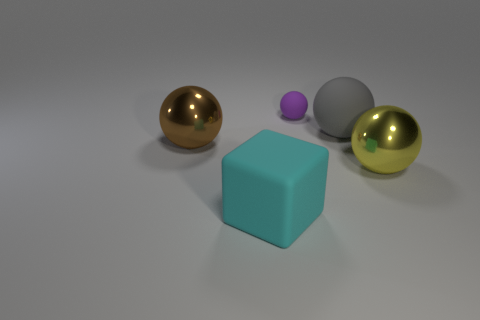Are there more small purple metallic spheres than cyan objects?
Make the answer very short. No. How many large rubber objects are both behind the brown shiny ball and on the left side of the purple sphere?
Your answer should be very brief. 0. Is there anything else that has the same size as the gray matte object?
Keep it short and to the point. Yes. Are there more purple matte spheres that are in front of the large brown sphere than large metal things that are right of the purple matte object?
Make the answer very short. No. There is a large ball to the left of the purple matte sphere; what is it made of?
Offer a very short reply. Metal. Does the large yellow metal object have the same shape as the tiny purple matte object that is to the left of the large gray rubber object?
Your response must be concise. Yes. There is a metallic thing that is behind the large metal thing on the right side of the purple sphere; how many yellow things are behind it?
Make the answer very short. 0. The other matte object that is the same shape as the big gray thing is what color?
Ensure brevity in your answer.  Purple. Is there any other thing that has the same shape as the large yellow metallic thing?
Your response must be concise. Yes. How many blocks are either tiny purple things or yellow shiny things?
Give a very brief answer. 0. 